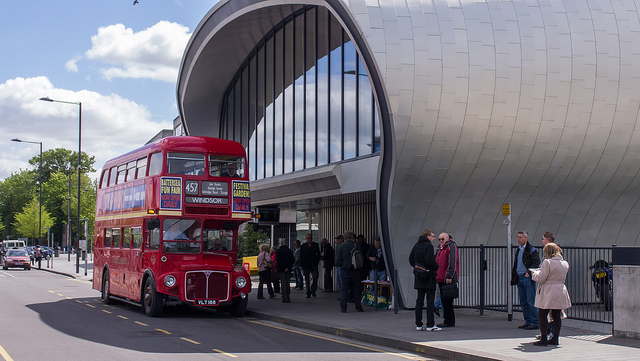Extract all visible text content from this image. 451 